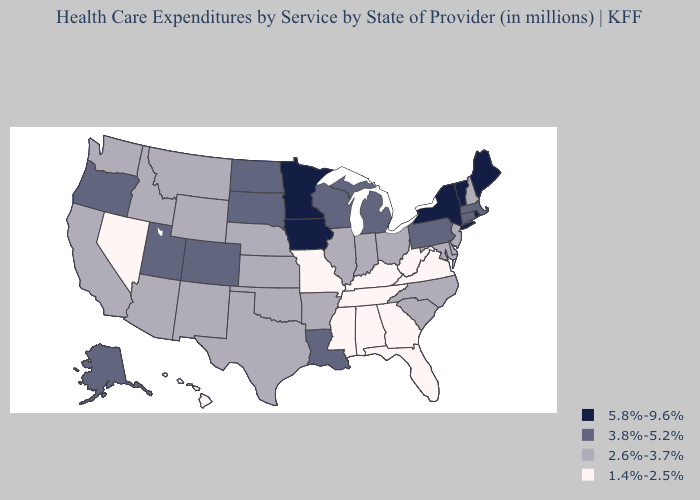Does Louisiana have a lower value than New York?
Write a very short answer. Yes. What is the value of Texas?
Answer briefly. 2.6%-3.7%. Among the states that border Indiana , does Kentucky have the lowest value?
Keep it brief. Yes. Which states have the lowest value in the MidWest?
Write a very short answer. Missouri. Does Oklahoma have the same value as New Mexico?
Give a very brief answer. Yes. What is the highest value in the USA?
Concise answer only. 5.8%-9.6%. Name the states that have a value in the range 3.8%-5.2%?
Keep it brief. Alaska, Colorado, Connecticut, Louisiana, Massachusetts, Michigan, North Dakota, Oregon, Pennsylvania, South Dakota, Utah, Wisconsin. Among the states that border New York , does Pennsylvania have the lowest value?
Quick response, please. No. What is the value of North Carolina?
Write a very short answer. 2.6%-3.7%. Name the states that have a value in the range 5.8%-9.6%?
Quick response, please. Iowa, Maine, Minnesota, New York, Rhode Island, Vermont. What is the value of Arkansas?
Keep it brief. 2.6%-3.7%. What is the value of Kansas?
Quick response, please. 2.6%-3.7%. What is the lowest value in states that border Ohio?
Give a very brief answer. 1.4%-2.5%. Name the states that have a value in the range 2.6%-3.7%?
Be succinct. Arizona, Arkansas, California, Delaware, Idaho, Illinois, Indiana, Kansas, Maryland, Montana, Nebraska, New Hampshire, New Jersey, New Mexico, North Carolina, Ohio, Oklahoma, South Carolina, Texas, Washington, Wyoming. Name the states that have a value in the range 2.6%-3.7%?
Answer briefly. Arizona, Arkansas, California, Delaware, Idaho, Illinois, Indiana, Kansas, Maryland, Montana, Nebraska, New Hampshire, New Jersey, New Mexico, North Carolina, Ohio, Oklahoma, South Carolina, Texas, Washington, Wyoming. 